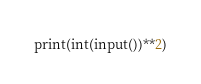<code> <loc_0><loc_0><loc_500><loc_500><_Python_>print(int(input())**2)</code> 